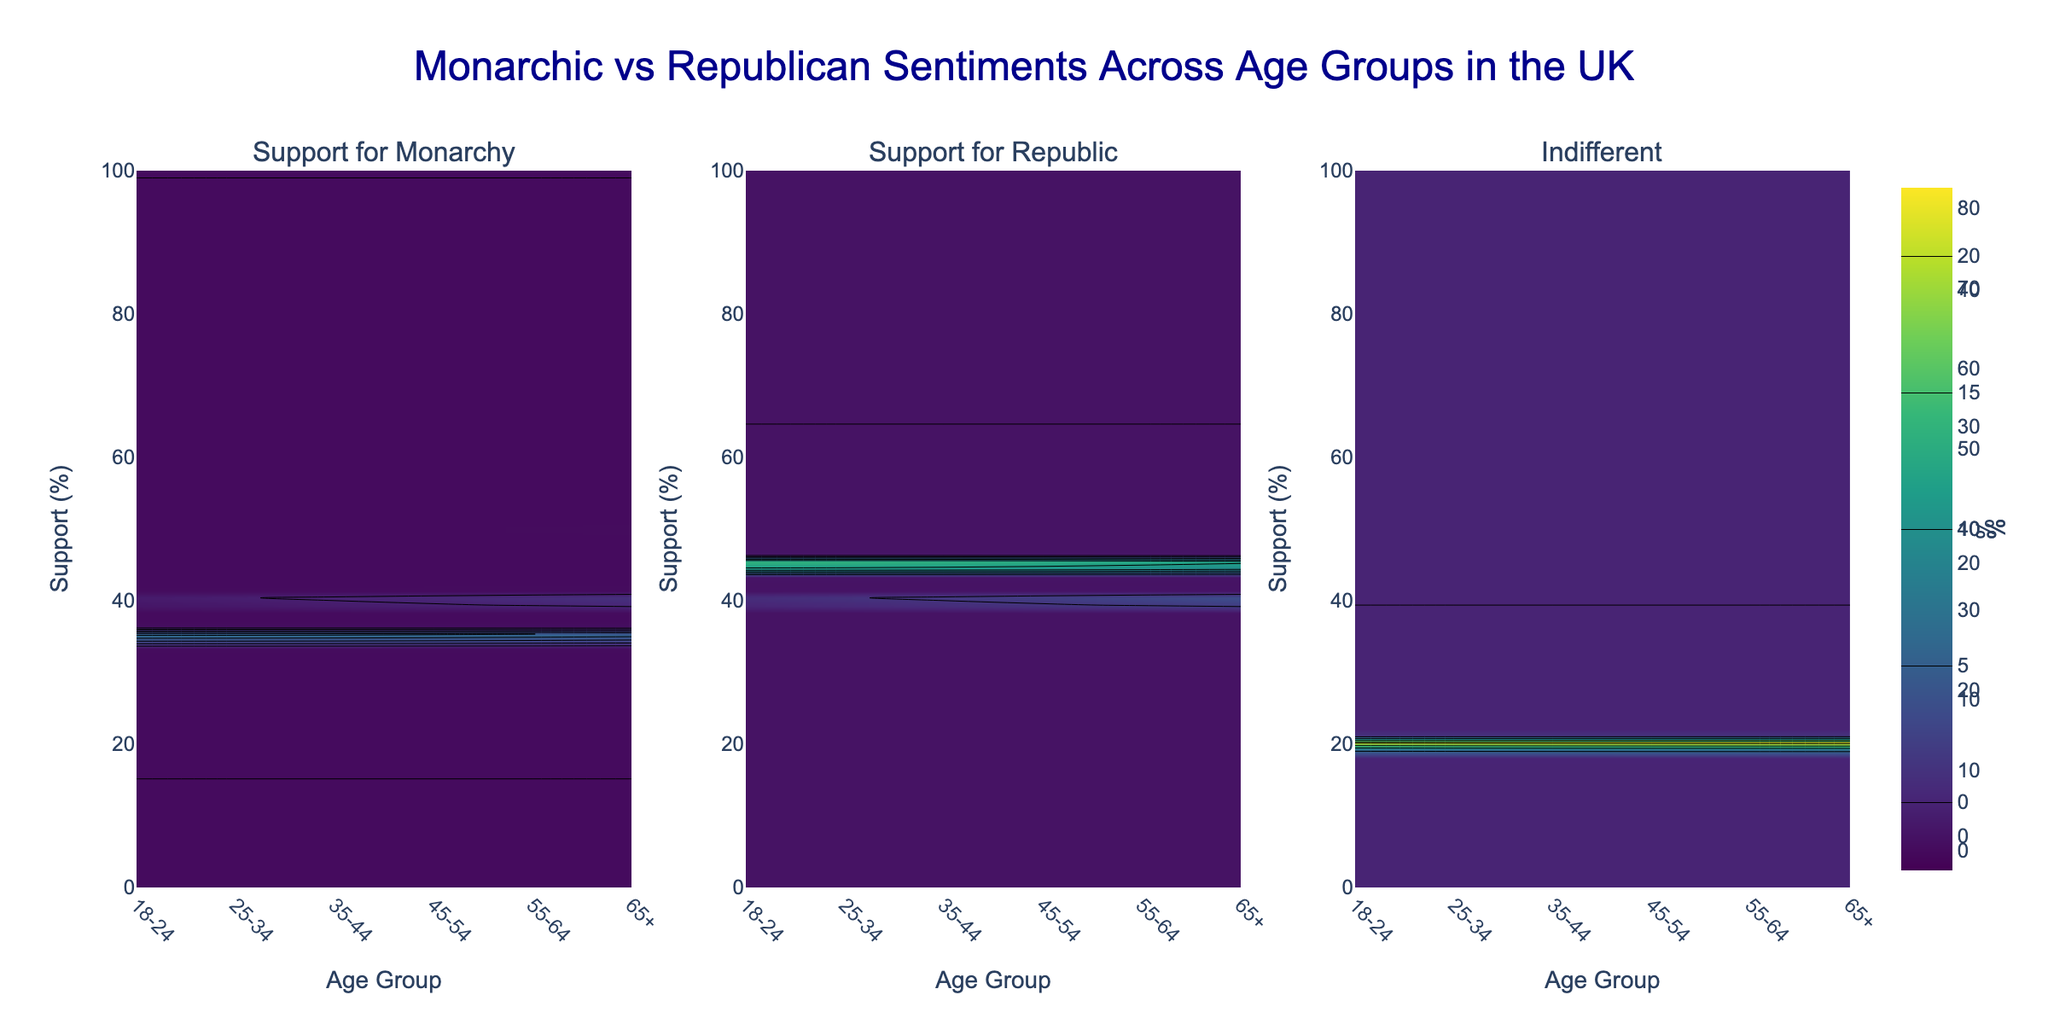What is the title of the figure? The title is written at the top center of the figure. It reads: "Monarchic vs Republican Sentiments Across Age Groups in the UK".
Answer: Monarchic vs Republican Sentiments Across Age Groups in the UK What are the three subplots in the figure? The subplots' titles indicate what each subplot represents. They are "Support for Monarchy", "Support for Republic", and "Indifferent".
Answer: Support for Monarchy, Support for Republic, Indifferent Which age group shows the highest support for the monarchy? By examining the contour plot in the "Support for Monarchy" subplot, the age group with a peak support percentage nearing 80% is evident, which is the "65+" age group.
Answer: 65+ Compare the support for the monarchy between the 18-24 and 65+ age groups. Reference the "Support for Monarchy" subplot and note the support percentage values for both age groups: the 18-24 group has around 35%, while the 65+ group shows around 80%. The difference is calculated as 80% - 35% = 45%.
Answer: 65+ age group has 45% more support Which age group is the least indifferent towards governance? The "Indifferent" subplot shows the lowest indifference percentage, which is around 10%, matching the age group "65+".
Answer: 65+ How does support for a republic change as age increases? By observing the "Support for Republic" subplot, it is evident that the support percentage decreases as the age group increases. Younger age groups (18-24) have the highest support around 45%, which reduces to 10% for the 65+ age group.
Answer: Decreases In terms of support percentages, which age group shows equal support for both monarchy and republic? By comparing values from both the "Support for Monarchy" and "Support for Republic" subplots, the 25-34 age group shows approximately equal support, both at 40%.
Answer: 25-34 What is the combined total percentage of those indifferent and those supporting the republic for the 35-44 age group? From the "Indifferent" and "Support for Republic" subplots, for the 35-44 age group, the indifferent percentage is 20% and the support for the republic is 30%. Adding these gives 20% + 30% = 50%.
Answer: 50% Which particular sentiment shows the most drastic change when moving from the 18-24 to the 65+ age group? Observing all subplots, "Support for Monarchy" shows the most drastic increase from 35% to 80%, compared to other sentiments. The difference is 80% - 35% = 45%.
Answer: Support for Monarchy What pattern can be observed in the indifferent sentiments across different age groups? The "Indifferent" subplot consistently shows that indifference percentages are relatively low, and the pattern indicates a slight overall decrease from younger to older age groups.
Answer: Slightly decreases 